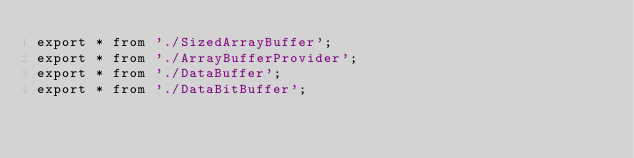<code> <loc_0><loc_0><loc_500><loc_500><_TypeScript_>export * from './SizedArrayBuffer';
export * from './ArrayBufferProvider';
export * from './DataBuffer';
export * from './DataBitBuffer';
</code> 